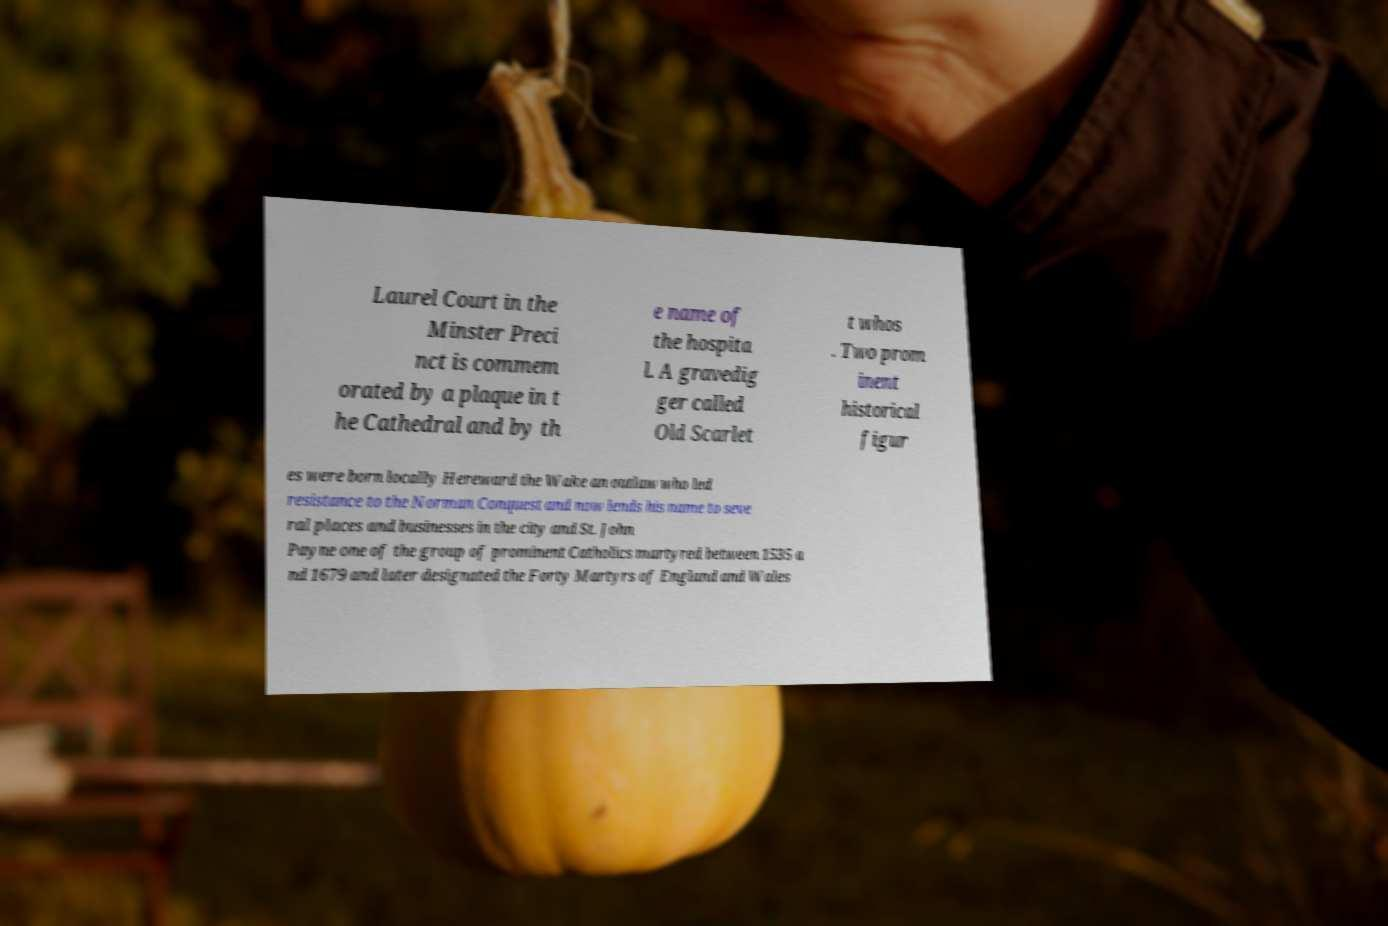For documentation purposes, I need the text within this image transcribed. Could you provide that? Laurel Court in the Minster Preci nct is commem orated by a plaque in t he Cathedral and by th e name of the hospita l. A gravedig ger called Old Scarlet t whos . Two prom inent historical figur es were born locally Hereward the Wake an outlaw who led resistance to the Norman Conquest and now lends his name to seve ral places and businesses in the city and St. John Payne one of the group of prominent Catholics martyred between 1535 a nd 1679 and later designated the Forty Martyrs of England and Wales 